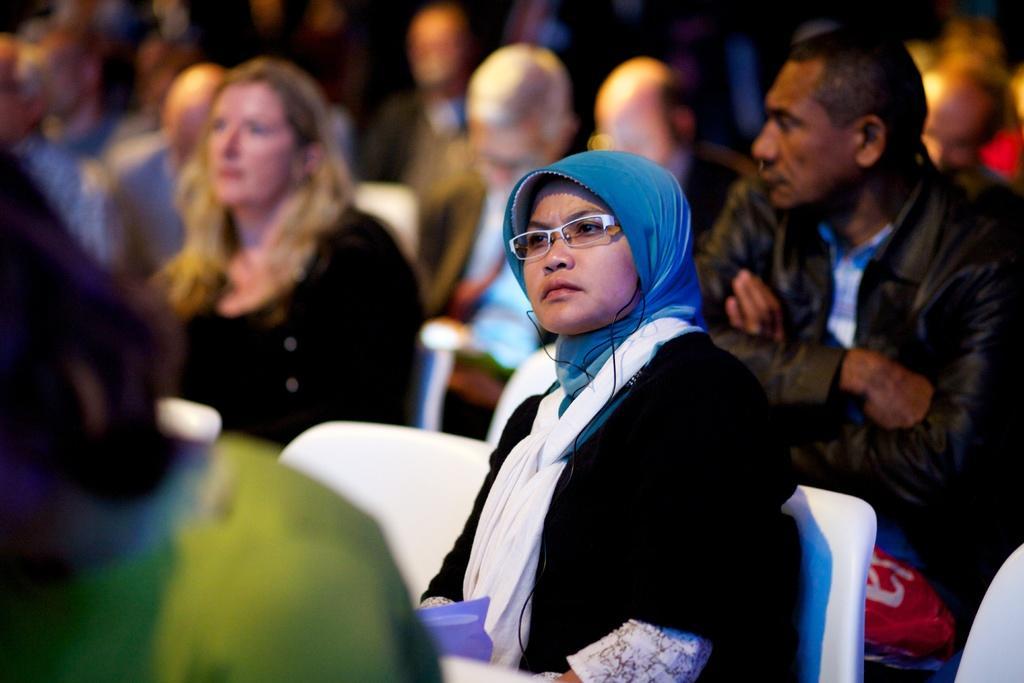Describe this image in one or two sentences. In this image, we can see a woman wearing glasses and sitting on a chair. That is in white color. Background there are few people also sitting we can see. 